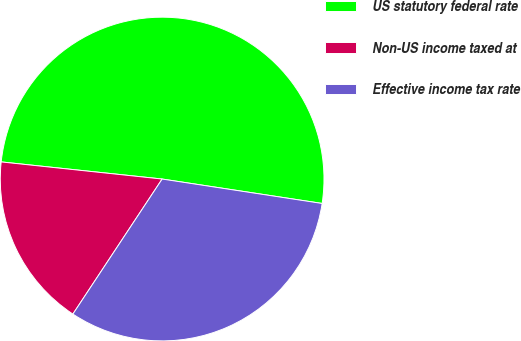Convert chart to OTSL. <chart><loc_0><loc_0><loc_500><loc_500><pie_chart><fcel>US statutory federal rate<fcel>Non-US income taxed at<fcel>Effective income tax rate<nl><fcel>50.72%<fcel>17.39%<fcel>31.88%<nl></chart> 